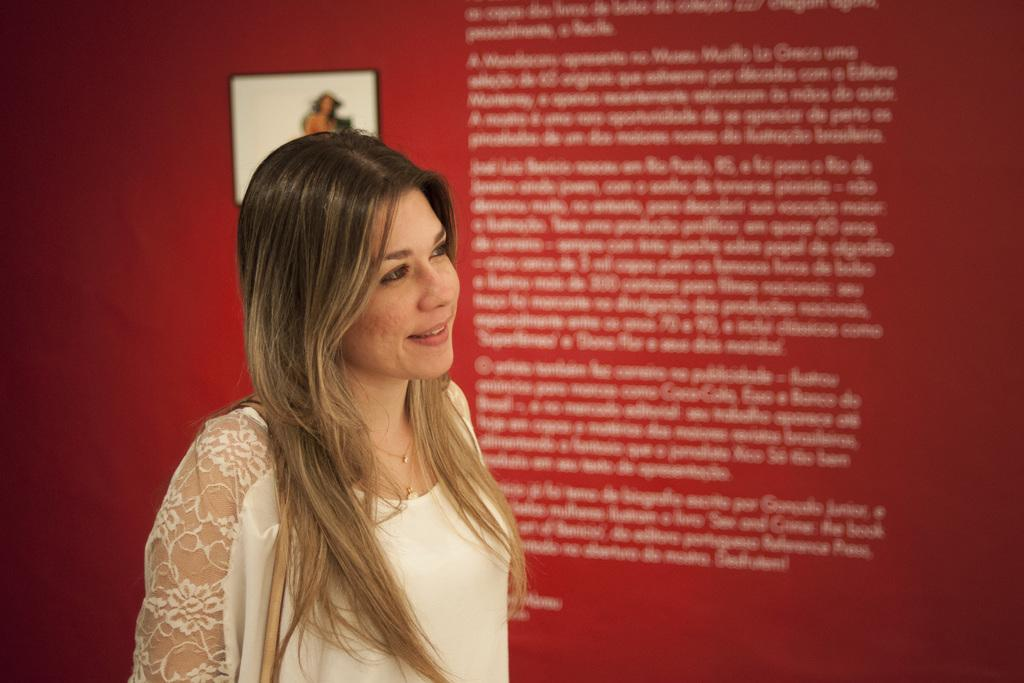Who is present in the image? There is a woman in the image. What is the woman doing in the image? The woman is standing in the image. What is the woman's facial expression in the image? The woman is smiling in the image. What can be seen in the background of the image? There is a red wall in the background of the image. What is written or depicted on the red wall? There is text on the red wall in the image. What is attached to the red wall in the image? There is a photo frame on the red wall in the image. Are there any giants visible in the image? No, there are no giants present in the image. Is there a beggar asking for money in the image? No, there is no beggar present in the image. 